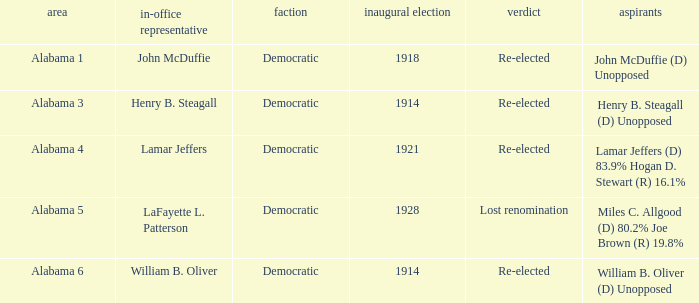What kind of party is the district in Alabama 1? Democratic. 